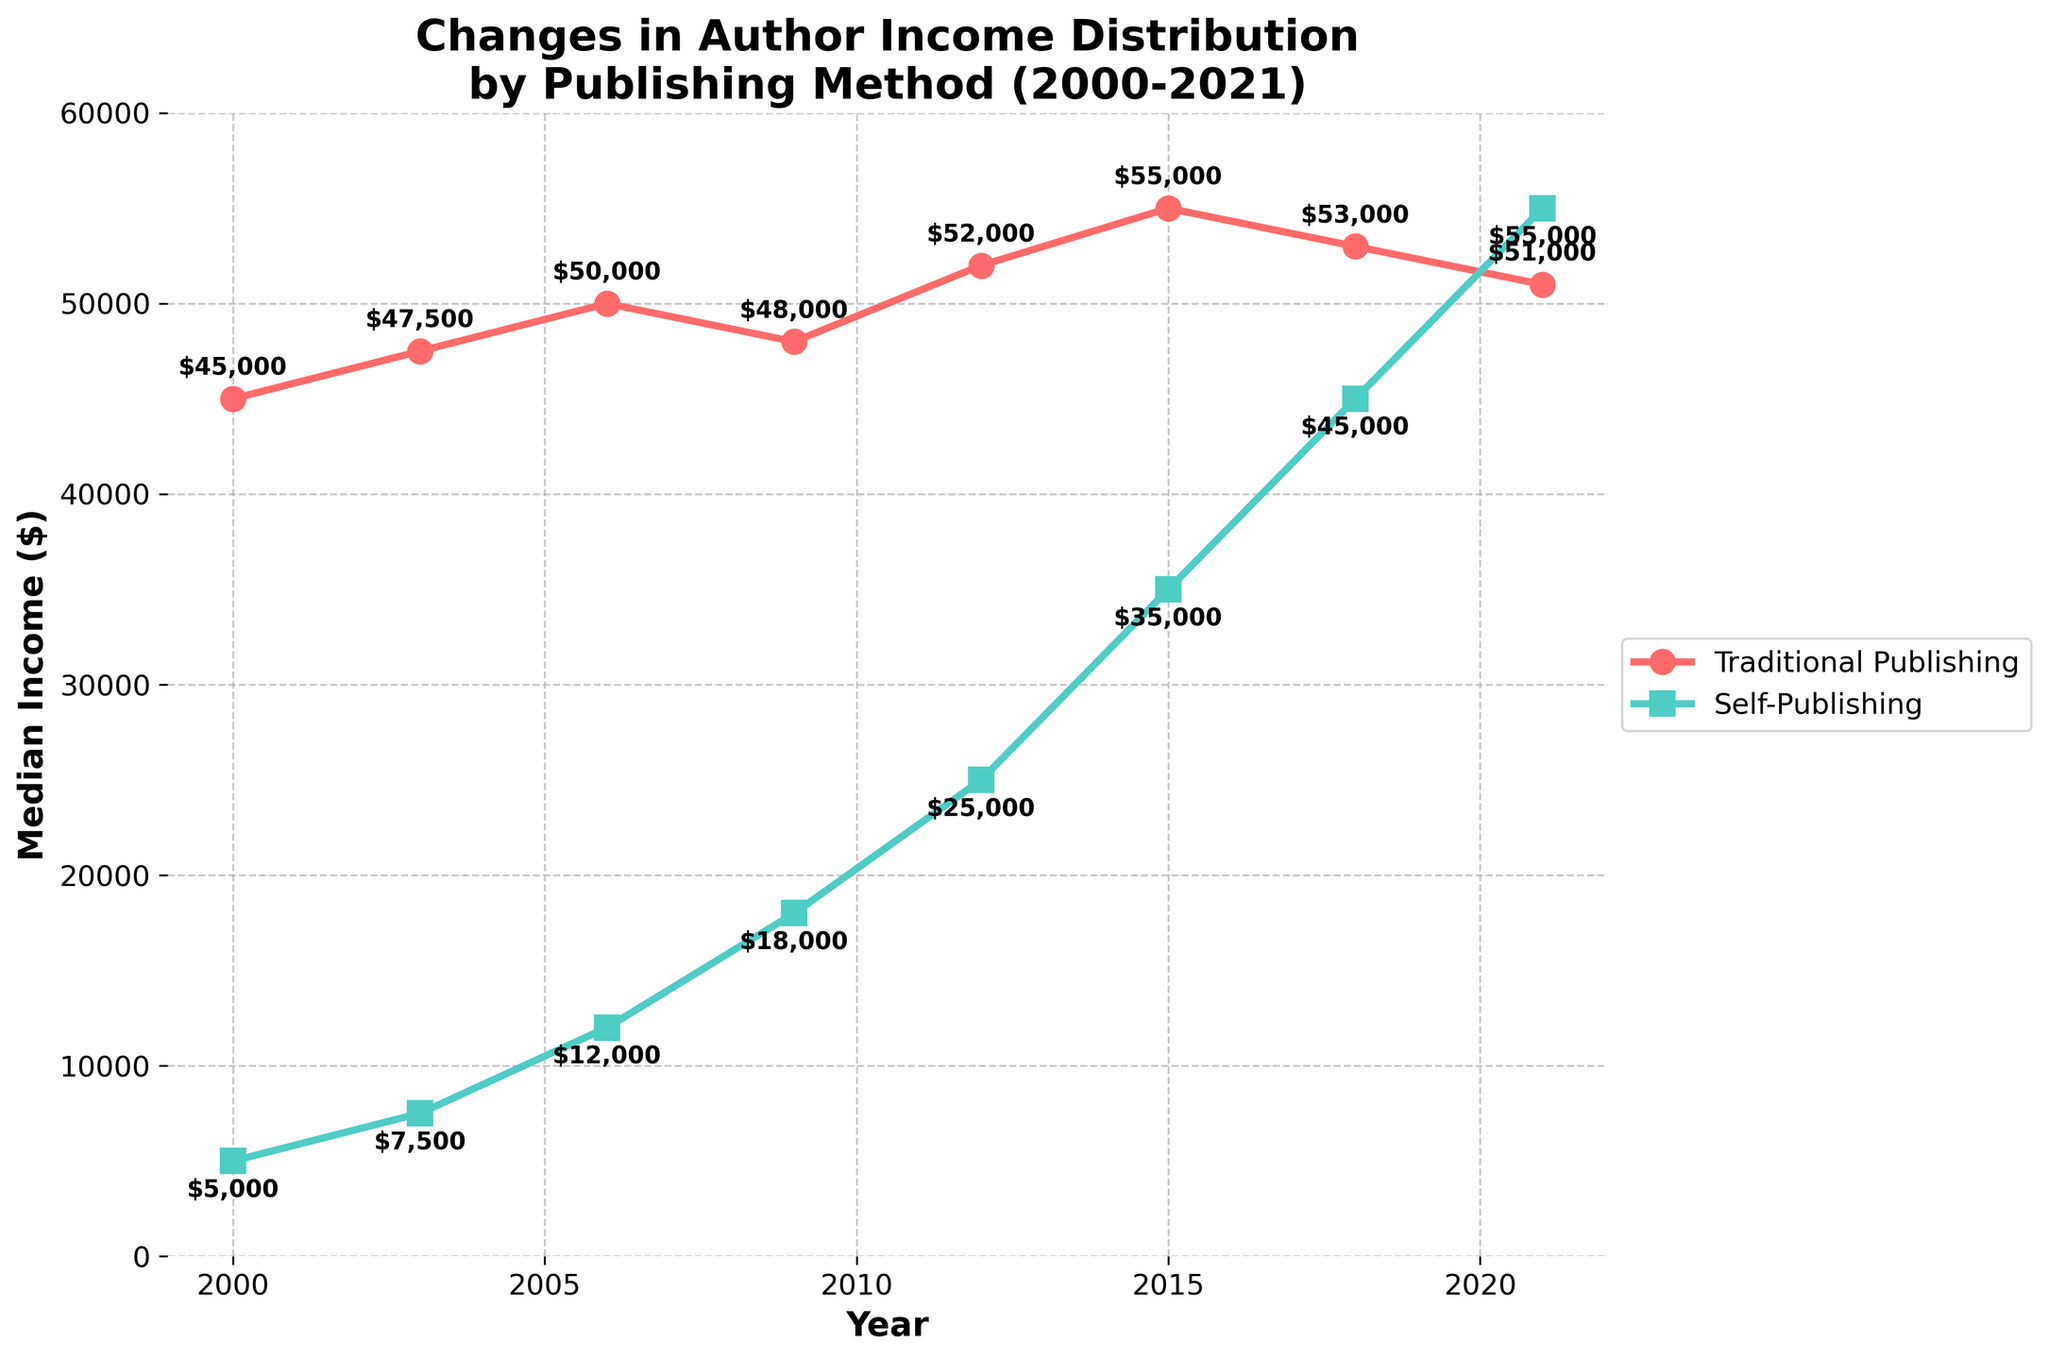What's the median income for traditional publishing and self-publishing in 2021? Look at the plot's data points for the year 2021, where traditional publishing is marked by a circle and self-publishing by a square. Identify their positions on the vertical axis which represents median income.
Answer: Traditional Publishing: $51,000, Self-Publishing: $55,000 How did the median income for self-publishing change from 2000 to 2021? Find the starting value in 2000 and the ending value in 2021 for self-publishing (marked by squares). Calculate the difference between these two values.
Answer: Increased by $50,000 Which publishing method had a higher median income in 2015, and by how much? Compare the positions of the data points for traditional and self-publishing in 2015. Calculate the difference between their vertical positions.
Answer: Traditional Publishing had a higher median income by $20,000 At which year did the income from self-publishing surpass the income from traditional publishing? Identify where the self-publishing curve (marked by squares) first goes above the traditional publishing curve (marked by circles).
Answer: 2021 What was the median income difference between traditional and self-publishing in 2006? Find the income values for both methods in 2006 and subtract self-publishing's income from traditional publishing's income.
Answer: $38,000 In which years did traditional publishing's median income decline compared to the previous recorded year? Look for points where the line for traditional publishing dips compared to its previous value.
Answer: 2009, 2018, 2021 What's the average median income for traditional publishing between 2000 and 2021? Sum up the median incomes for traditional publishing over the years provided and divide by the number of years (8).
Answer: $50,750 By how much did the median income of self-publishing increase from 2012 to 2015? Find the income values for self-publishing in 2012 and 2015, and calculate the difference between these two values.
Answer: $10,000 Which curve, traditional or self-publishing, shows more significant growth over the years? Compare the overall rise from 2000 to 2021 for both curves. Traditional publishing started at $45,000 and ended at $51,000, while self-publishing started at $5,000 and ended at $55,000.
Answer: Self-Publishing At what point did the gap between traditional and self-publishing median incomes narrow the most? Identify the year where the difference between the two median incomes is the smallest. Analyze the annotated values visually for the least difference.
Answer: 2021 